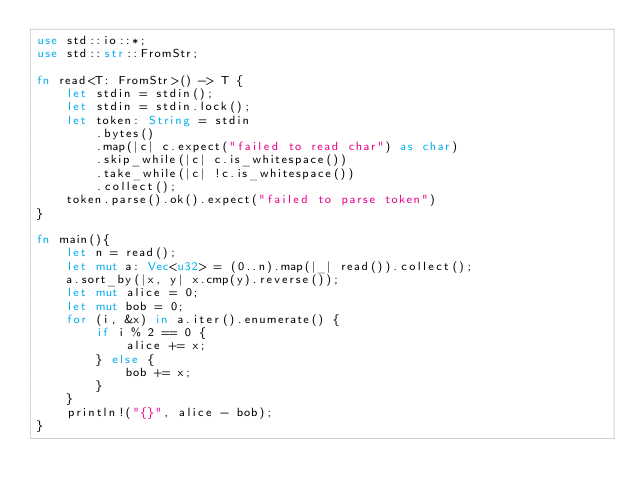<code> <loc_0><loc_0><loc_500><loc_500><_Rust_>use std::io::*;
use std::str::FromStr;

fn read<T: FromStr>() -> T {
    let stdin = stdin();
    let stdin = stdin.lock();
    let token: String = stdin
        .bytes()
        .map(|c| c.expect("failed to read char") as char) 
        .skip_while(|c| c.is_whitespace())
        .take_while(|c| !c.is_whitespace())
        .collect();
    token.parse().ok().expect("failed to parse token")
}

fn main(){
    let n = read();
    let mut a: Vec<u32> = (0..n).map(|_| read()).collect();
    a.sort_by(|x, y| x.cmp(y).reverse());
    let mut alice = 0;
    let mut bob = 0;
    for (i, &x) in a.iter().enumerate() {
        if i % 2 == 0 {
            alice += x;
        } else {
            bob += x;
        }
    }
    println!("{}", alice - bob);
}</code> 